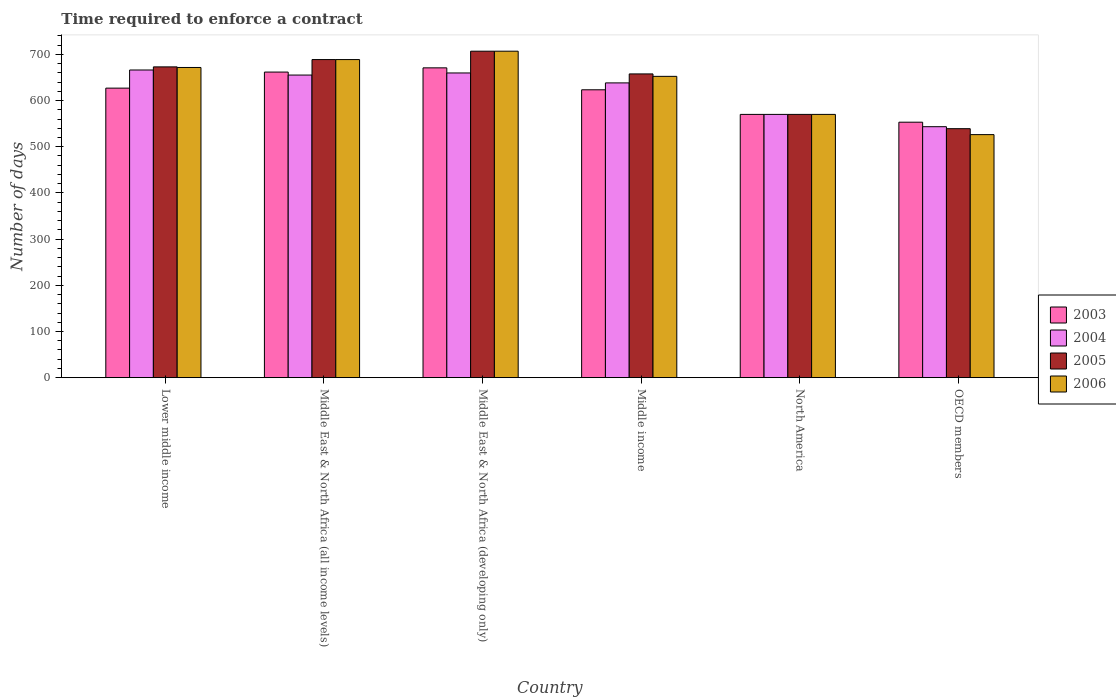How many groups of bars are there?
Provide a succinct answer. 6. Are the number of bars per tick equal to the number of legend labels?
Offer a terse response. Yes. Are the number of bars on each tick of the X-axis equal?
Your answer should be very brief. Yes. How many bars are there on the 2nd tick from the left?
Offer a very short reply. 4. In how many cases, is the number of bars for a given country not equal to the number of legend labels?
Make the answer very short. 0. What is the number of days required to enforce a contract in 2004 in OECD members?
Give a very brief answer. 543.37. Across all countries, what is the maximum number of days required to enforce a contract in 2004?
Keep it short and to the point. 666.15. Across all countries, what is the minimum number of days required to enforce a contract in 2006?
Your answer should be very brief. 526.23. In which country was the number of days required to enforce a contract in 2006 maximum?
Your response must be concise. Middle East & North Africa (developing only). What is the total number of days required to enforce a contract in 2006 in the graph?
Give a very brief answer. 3815.74. What is the difference between the number of days required to enforce a contract in 2004 in Middle East & North Africa (developing only) and that in Middle income?
Provide a short and direct response. 21.52. What is the difference between the number of days required to enforce a contract in 2003 in North America and the number of days required to enforce a contract in 2004 in OECD members?
Your response must be concise. 26.63. What is the average number of days required to enforce a contract in 2004 per country?
Provide a succinct answer. 622.11. What is the difference between the number of days required to enforce a contract of/in 2006 and number of days required to enforce a contract of/in 2004 in North America?
Give a very brief answer. 0. What is the ratio of the number of days required to enforce a contract in 2006 in Middle East & North Africa (all income levels) to that in Middle income?
Give a very brief answer. 1.06. Is the difference between the number of days required to enforce a contract in 2006 in Middle East & North Africa (developing only) and OECD members greater than the difference between the number of days required to enforce a contract in 2004 in Middle East & North Africa (developing only) and OECD members?
Your answer should be very brief. Yes. What is the difference between the highest and the second highest number of days required to enforce a contract in 2006?
Provide a short and direct response. -18.13. What is the difference between the highest and the lowest number of days required to enforce a contract in 2006?
Your answer should be very brief. 180.61. In how many countries, is the number of days required to enforce a contract in 2005 greater than the average number of days required to enforce a contract in 2005 taken over all countries?
Make the answer very short. 4. Is it the case that in every country, the sum of the number of days required to enforce a contract in 2003 and number of days required to enforce a contract in 2004 is greater than the sum of number of days required to enforce a contract in 2005 and number of days required to enforce a contract in 2006?
Keep it short and to the point. No. What does the 3rd bar from the left in Middle income represents?
Ensure brevity in your answer.  2005. Is it the case that in every country, the sum of the number of days required to enforce a contract in 2006 and number of days required to enforce a contract in 2003 is greater than the number of days required to enforce a contract in 2004?
Make the answer very short. Yes. Are all the bars in the graph horizontal?
Ensure brevity in your answer.  No. How many countries are there in the graph?
Offer a very short reply. 6. Are the values on the major ticks of Y-axis written in scientific E-notation?
Keep it short and to the point. No. Does the graph contain grids?
Offer a terse response. No. Where does the legend appear in the graph?
Your answer should be very brief. Center right. How many legend labels are there?
Keep it short and to the point. 4. What is the title of the graph?
Provide a succinct answer. Time required to enforce a contract. Does "1996" appear as one of the legend labels in the graph?
Your response must be concise. No. What is the label or title of the X-axis?
Your response must be concise. Country. What is the label or title of the Y-axis?
Give a very brief answer. Number of days. What is the Number of days in 2003 in Lower middle income?
Provide a short and direct response. 626.86. What is the Number of days in 2004 in Lower middle income?
Ensure brevity in your answer.  666.15. What is the Number of days of 2005 in Lower middle income?
Your answer should be very brief. 672.89. What is the Number of days in 2006 in Lower middle income?
Provide a succinct answer. 671.59. What is the Number of days of 2003 in Middle East & North Africa (all income levels)?
Ensure brevity in your answer.  661.64. What is the Number of days in 2004 in Middle East & North Africa (all income levels)?
Your answer should be very brief. 655.19. What is the Number of days in 2005 in Middle East & North Africa (all income levels)?
Offer a very short reply. 688.71. What is the Number of days in 2006 in Middle East & North Africa (all income levels)?
Keep it short and to the point. 688.71. What is the Number of days of 2003 in Middle East & North Africa (developing only)?
Your response must be concise. 670.78. What is the Number of days in 2004 in Middle East & North Africa (developing only)?
Your response must be concise. 659.73. What is the Number of days of 2005 in Middle East & North Africa (developing only)?
Your response must be concise. 706.83. What is the Number of days of 2006 in Middle East & North Africa (developing only)?
Ensure brevity in your answer.  706.83. What is the Number of days of 2003 in Middle income?
Provide a succinct answer. 623.29. What is the Number of days of 2004 in Middle income?
Offer a very short reply. 638.21. What is the Number of days in 2005 in Middle income?
Offer a terse response. 657.65. What is the Number of days of 2006 in Middle income?
Your response must be concise. 652.38. What is the Number of days of 2003 in North America?
Keep it short and to the point. 570. What is the Number of days of 2004 in North America?
Offer a terse response. 570. What is the Number of days of 2005 in North America?
Your response must be concise. 570. What is the Number of days of 2006 in North America?
Your response must be concise. 570. What is the Number of days of 2003 in OECD members?
Your response must be concise. 553.1. What is the Number of days in 2004 in OECD members?
Give a very brief answer. 543.37. What is the Number of days in 2005 in OECD members?
Keep it short and to the point. 539.07. What is the Number of days of 2006 in OECD members?
Ensure brevity in your answer.  526.23. Across all countries, what is the maximum Number of days in 2003?
Give a very brief answer. 670.78. Across all countries, what is the maximum Number of days in 2004?
Make the answer very short. 666.15. Across all countries, what is the maximum Number of days of 2005?
Provide a short and direct response. 706.83. Across all countries, what is the maximum Number of days in 2006?
Your response must be concise. 706.83. Across all countries, what is the minimum Number of days of 2003?
Provide a short and direct response. 553.1. Across all countries, what is the minimum Number of days of 2004?
Your answer should be very brief. 543.37. Across all countries, what is the minimum Number of days of 2005?
Keep it short and to the point. 539.07. Across all countries, what is the minimum Number of days of 2006?
Your answer should be compact. 526.23. What is the total Number of days of 2003 in the graph?
Your response must be concise. 3705.67. What is the total Number of days in 2004 in the graph?
Keep it short and to the point. 3732.64. What is the total Number of days of 2005 in the graph?
Give a very brief answer. 3835.14. What is the total Number of days of 2006 in the graph?
Provide a short and direct response. 3815.74. What is the difference between the Number of days in 2003 in Lower middle income and that in Middle East & North Africa (all income levels)?
Your response must be concise. -34.79. What is the difference between the Number of days in 2004 in Lower middle income and that in Middle East & North Africa (all income levels)?
Provide a short and direct response. 10.96. What is the difference between the Number of days in 2005 in Lower middle income and that in Middle East & North Africa (all income levels)?
Give a very brief answer. -15.82. What is the difference between the Number of days in 2006 in Lower middle income and that in Middle East & North Africa (all income levels)?
Your response must be concise. -17.11. What is the difference between the Number of days in 2003 in Lower middle income and that in Middle East & North Africa (developing only)?
Ensure brevity in your answer.  -43.92. What is the difference between the Number of days of 2004 in Lower middle income and that in Middle East & North Africa (developing only)?
Your response must be concise. 6.42. What is the difference between the Number of days in 2005 in Lower middle income and that in Middle East & North Africa (developing only)?
Give a very brief answer. -33.95. What is the difference between the Number of days of 2006 in Lower middle income and that in Middle East & North Africa (developing only)?
Provide a short and direct response. -35.24. What is the difference between the Number of days in 2003 in Lower middle income and that in Middle income?
Ensure brevity in your answer.  3.57. What is the difference between the Number of days of 2004 in Lower middle income and that in Middle income?
Make the answer very short. 27.94. What is the difference between the Number of days in 2005 in Lower middle income and that in Middle income?
Provide a short and direct response. 15.24. What is the difference between the Number of days in 2006 in Lower middle income and that in Middle income?
Your response must be concise. 19.21. What is the difference between the Number of days in 2003 in Lower middle income and that in North America?
Your answer should be compact. 56.86. What is the difference between the Number of days in 2004 in Lower middle income and that in North America?
Offer a very short reply. 96.15. What is the difference between the Number of days of 2005 in Lower middle income and that in North America?
Keep it short and to the point. 102.89. What is the difference between the Number of days of 2006 in Lower middle income and that in North America?
Ensure brevity in your answer.  101.59. What is the difference between the Number of days in 2003 in Lower middle income and that in OECD members?
Keep it short and to the point. 73.75. What is the difference between the Number of days of 2004 in Lower middle income and that in OECD members?
Give a very brief answer. 122.78. What is the difference between the Number of days in 2005 in Lower middle income and that in OECD members?
Keep it short and to the point. 133.82. What is the difference between the Number of days in 2006 in Lower middle income and that in OECD members?
Make the answer very short. 145.37. What is the difference between the Number of days of 2003 in Middle East & North Africa (all income levels) and that in Middle East & North Africa (developing only)?
Your answer should be very brief. -9.13. What is the difference between the Number of days in 2004 in Middle East & North Africa (all income levels) and that in Middle East & North Africa (developing only)?
Provide a succinct answer. -4.54. What is the difference between the Number of days of 2005 in Middle East & North Africa (all income levels) and that in Middle East & North Africa (developing only)?
Offer a very short reply. -18.13. What is the difference between the Number of days of 2006 in Middle East & North Africa (all income levels) and that in Middle East & North Africa (developing only)?
Give a very brief answer. -18.13. What is the difference between the Number of days of 2003 in Middle East & North Africa (all income levels) and that in Middle income?
Offer a terse response. 38.36. What is the difference between the Number of days of 2004 in Middle East & North Africa (all income levels) and that in Middle income?
Your answer should be compact. 16.98. What is the difference between the Number of days of 2005 in Middle East & North Africa (all income levels) and that in Middle income?
Your response must be concise. 31.06. What is the difference between the Number of days in 2006 in Middle East & North Africa (all income levels) and that in Middle income?
Your answer should be compact. 36.32. What is the difference between the Number of days in 2003 in Middle East & North Africa (all income levels) and that in North America?
Offer a very short reply. 91.64. What is the difference between the Number of days in 2004 in Middle East & North Africa (all income levels) and that in North America?
Offer a terse response. 85.19. What is the difference between the Number of days of 2005 in Middle East & North Africa (all income levels) and that in North America?
Keep it short and to the point. 118.71. What is the difference between the Number of days in 2006 in Middle East & North Africa (all income levels) and that in North America?
Offer a terse response. 118.71. What is the difference between the Number of days of 2003 in Middle East & North Africa (all income levels) and that in OECD members?
Your response must be concise. 108.54. What is the difference between the Number of days in 2004 in Middle East & North Africa (all income levels) and that in OECD members?
Ensure brevity in your answer.  111.82. What is the difference between the Number of days of 2005 in Middle East & North Africa (all income levels) and that in OECD members?
Your response must be concise. 149.64. What is the difference between the Number of days of 2006 in Middle East & North Africa (all income levels) and that in OECD members?
Keep it short and to the point. 162.48. What is the difference between the Number of days in 2003 in Middle East & North Africa (developing only) and that in Middle income?
Keep it short and to the point. 47.49. What is the difference between the Number of days of 2004 in Middle East & North Africa (developing only) and that in Middle income?
Give a very brief answer. 21.52. What is the difference between the Number of days of 2005 in Middle East & North Africa (developing only) and that in Middle income?
Provide a succinct answer. 49.19. What is the difference between the Number of days of 2006 in Middle East & North Africa (developing only) and that in Middle income?
Your answer should be very brief. 54.45. What is the difference between the Number of days in 2003 in Middle East & North Africa (developing only) and that in North America?
Your answer should be compact. 100.78. What is the difference between the Number of days in 2004 in Middle East & North Africa (developing only) and that in North America?
Offer a very short reply. 89.73. What is the difference between the Number of days in 2005 in Middle East & North Africa (developing only) and that in North America?
Your answer should be very brief. 136.83. What is the difference between the Number of days of 2006 in Middle East & North Africa (developing only) and that in North America?
Provide a succinct answer. 136.83. What is the difference between the Number of days of 2003 in Middle East & North Africa (developing only) and that in OECD members?
Your answer should be compact. 117.67. What is the difference between the Number of days of 2004 in Middle East & North Africa (developing only) and that in OECD members?
Your answer should be very brief. 116.36. What is the difference between the Number of days of 2005 in Middle East & North Africa (developing only) and that in OECD members?
Ensure brevity in your answer.  167.77. What is the difference between the Number of days of 2006 in Middle East & North Africa (developing only) and that in OECD members?
Ensure brevity in your answer.  180.61. What is the difference between the Number of days in 2003 in Middle income and that in North America?
Give a very brief answer. 53.29. What is the difference between the Number of days of 2004 in Middle income and that in North America?
Offer a very short reply. 68.21. What is the difference between the Number of days in 2005 in Middle income and that in North America?
Provide a succinct answer. 87.65. What is the difference between the Number of days of 2006 in Middle income and that in North America?
Provide a succinct answer. 82.38. What is the difference between the Number of days of 2003 in Middle income and that in OECD members?
Provide a succinct answer. 70.18. What is the difference between the Number of days of 2004 in Middle income and that in OECD members?
Make the answer very short. 94.84. What is the difference between the Number of days of 2005 in Middle income and that in OECD members?
Offer a very short reply. 118.58. What is the difference between the Number of days of 2006 in Middle income and that in OECD members?
Your answer should be very brief. 126.16. What is the difference between the Number of days of 2003 in North America and that in OECD members?
Offer a terse response. 16.9. What is the difference between the Number of days in 2004 in North America and that in OECD members?
Offer a very short reply. 26.63. What is the difference between the Number of days in 2005 in North America and that in OECD members?
Provide a succinct answer. 30.93. What is the difference between the Number of days of 2006 in North America and that in OECD members?
Provide a succinct answer. 43.77. What is the difference between the Number of days of 2003 in Lower middle income and the Number of days of 2004 in Middle East & North Africa (all income levels)?
Provide a short and direct response. -28.33. What is the difference between the Number of days of 2003 in Lower middle income and the Number of days of 2005 in Middle East & North Africa (all income levels)?
Keep it short and to the point. -61.85. What is the difference between the Number of days in 2003 in Lower middle income and the Number of days in 2006 in Middle East & North Africa (all income levels)?
Ensure brevity in your answer.  -61.85. What is the difference between the Number of days of 2004 in Lower middle income and the Number of days of 2005 in Middle East & North Africa (all income levels)?
Offer a very short reply. -22.56. What is the difference between the Number of days in 2004 in Lower middle income and the Number of days in 2006 in Middle East & North Africa (all income levels)?
Provide a short and direct response. -22.56. What is the difference between the Number of days in 2005 in Lower middle income and the Number of days in 2006 in Middle East & North Africa (all income levels)?
Your response must be concise. -15.82. What is the difference between the Number of days of 2003 in Lower middle income and the Number of days of 2004 in Middle East & North Africa (developing only)?
Your answer should be very brief. -32.87. What is the difference between the Number of days in 2003 in Lower middle income and the Number of days in 2005 in Middle East & North Africa (developing only)?
Offer a very short reply. -79.98. What is the difference between the Number of days of 2003 in Lower middle income and the Number of days of 2006 in Middle East & North Africa (developing only)?
Provide a short and direct response. -79.98. What is the difference between the Number of days in 2004 in Lower middle income and the Number of days in 2005 in Middle East & North Africa (developing only)?
Keep it short and to the point. -40.68. What is the difference between the Number of days in 2004 in Lower middle income and the Number of days in 2006 in Middle East & North Africa (developing only)?
Keep it short and to the point. -40.68. What is the difference between the Number of days in 2005 in Lower middle income and the Number of days in 2006 in Middle East & North Africa (developing only)?
Keep it short and to the point. -33.95. What is the difference between the Number of days in 2003 in Lower middle income and the Number of days in 2004 in Middle income?
Provide a short and direct response. -11.35. What is the difference between the Number of days of 2003 in Lower middle income and the Number of days of 2005 in Middle income?
Offer a very short reply. -30.79. What is the difference between the Number of days of 2003 in Lower middle income and the Number of days of 2006 in Middle income?
Your response must be concise. -25.52. What is the difference between the Number of days of 2004 in Lower middle income and the Number of days of 2005 in Middle income?
Your response must be concise. 8.5. What is the difference between the Number of days in 2004 in Lower middle income and the Number of days in 2006 in Middle income?
Offer a terse response. 13.77. What is the difference between the Number of days of 2005 in Lower middle income and the Number of days of 2006 in Middle income?
Provide a short and direct response. 20.5. What is the difference between the Number of days of 2003 in Lower middle income and the Number of days of 2004 in North America?
Offer a terse response. 56.86. What is the difference between the Number of days in 2003 in Lower middle income and the Number of days in 2005 in North America?
Your answer should be very brief. 56.86. What is the difference between the Number of days of 2003 in Lower middle income and the Number of days of 2006 in North America?
Your response must be concise. 56.86. What is the difference between the Number of days in 2004 in Lower middle income and the Number of days in 2005 in North America?
Your answer should be very brief. 96.15. What is the difference between the Number of days in 2004 in Lower middle income and the Number of days in 2006 in North America?
Your answer should be very brief. 96.15. What is the difference between the Number of days in 2005 in Lower middle income and the Number of days in 2006 in North America?
Ensure brevity in your answer.  102.89. What is the difference between the Number of days in 2003 in Lower middle income and the Number of days in 2004 in OECD members?
Give a very brief answer. 83.49. What is the difference between the Number of days in 2003 in Lower middle income and the Number of days in 2005 in OECD members?
Offer a terse response. 87.79. What is the difference between the Number of days of 2003 in Lower middle income and the Number of days of 2006 in OECD members?
Your answer should be very brief. 100.63. What is the difference between the Number of days in 2004 in Lower middle income and the Number of days in 2005 in OECD members?
Offer a terse response. 127.08. What is the difference between the Number of days in 2004 in Lower middle income and the Number of days in 2006 in OECD members?
Keep it short and to the point. 139.92. What is the difference between the Number of days of 2005 in Lower middle income and the Number of days of 2006 in OECD members?
Keep it short and to the point. 146.66. What is the difference between the Number of days of 2003 in Middle East & North Africa (all income levels) and the Number of days of 2004 in Middle East & North Africa (developing only)?
Provide a succinct answer. 1.92. What is the difference between the Number of days of 2003 in Middle East & North Africa (all income levels) and the Number of days of 2005 in Middle East & North Africa (developing only)?
Your answer should be very brief. -45.19. What is the difference between the Number of days of 2003 in Middle East & North Africa (all income levels) and the Number of days of 2006 in Middle East & North Africa (developing only)?
Ensure brevity in your answer.  -45.19. What is the difference between the Number of days in 2004 in Middle East & North Africa (all income levels) and the Number of days in 2005 in Middle East & North Africa (developing only)?
Ensure brevity in your answer.  -51.65. What is the difference between the Number of days of 2004 in Middle East & North Africa (all income levels) and the Number of days of 2006 in Middle East & North Africa (developing only)?
Your response must be concise. -51.65. What is the difference between the Number of days of 2005 in Middle East & North Africa (all income levels) and the Number of days of 2006 in Middle East & North Africa (developing only)?
Keep it short and to the point. -18.13. What is the difference between the Number of days in 2003 in Middle East & North Africa (all income levels) and the Number of days in 2004 in Middle income?
Offer a very short reply. 23.44. What is the difference between the Number of days in 2003 in Middle East & North Africa (all income levels) and the Number of days in 2005 in Middle income?
Provide a short and direct response. 4. What is the difference between the Number of days of 2003 in Middle East & North Africa (all income levels) and the Number of days of 2006 in Middle income?
Your response must be concise. 9.26. What is the difference between the Number of days in 2004 in Middle East & North Africa (all income levels) and the Number of days in 2005 in Middle income?
Ensure brevity in your answer.  -2.46. What is the difference between the Number of days of 2004 in Middle East & North Africa (all income levels) and the Number of days of 2006 in Middle income?
Ensure brevity in your answer.  2.81. What is the difference between the Number of days in 2005 in Middle East & North Africa (all income levels) and the Number of days in 2006 in Middle income?
Ensure brevity in your answer.  36.32. What is the difference between the Number of days of 2003 in Middle East & North Africa (all income levels) and the Number of days of 2004 in North America?
Your answer should be compact. 91.64. What is the difference between the Number of days of 2003 in Middle East & North Africa (all income levels) and the Number of days of 2005 in North America?
Your answer should be very brief. 91.64. What is the difference between the Number of days of 2003 in Middle East & North Africa (all income levels) and the Number of days of 2006 in North America?
Keep it short and to the point. 91.64. What is the difference between the Number of days of 2004 in Middle East & North Africa (all income levels) and the Number of days of 2005 in North America?
Make the answer very short. 85.19. What is the difference between the Number of days in 2004 in Middle East & North Africa (all income levels) and the Number of days in 2006 in North America?
Ensure brevity in your answer.  85.19. What is the difference between the Number of days of 2005 in Middle East & North Africa (all income levels) and the Number of days of 2006 in North America?
Ensure brevity in your answer.  118.71. What is the difference between the Number of days of 2003 in Middle East & North Africa (all income levels) and the Number of days of 2004 in OECD members?
Provide a succinct answer. 118.28. What is the difference between the Number of days of 2003 in Middle East & North Africa (all income levels) and the Number of days of 2005 in OECD members?
Provide a short and direct response. 122.58. What is the difference between the Number of days in 2003 in Middle East & North Africa (all income levels) and the Number of days in 2006 in OECD members?
Your response must be concise. 135.42. What is the difference between the Number of days in 2004 in Middle East & North Africa (all income levels) and the Number of days in 2005 in OECD members?
Offer a very short reply. 116.12. What is the difference between the Number of days in 2004 in Middle East & North Africa (all income levels) and the Number of days in 2006 in OECD members?
Give a very brief answer. 128.96. What is the difference between the Number of days in 2005 in Middle East & North Africa (all income levels) and the Number of days in 2006 in OECD members?
Your answer should be compact. 162.48. What is the difference between the Number of days of 2003 in Middle East & North Africa (developing only) and the Number of days of 2004 in Middle income?
Your answer should be very brief. 32.57. What is the difference between the Number of days of 2003 in Middle East & North Africa (developing only) and the Number of days of 2005 in Middle income?
Offer a terse response. 13.13. What is the difference between the Number of days of 2003 in Middle East & North Africa (developing only) and the Number of days of 2006 in Middle income?
Provide a succinct answer. 18.4. What is the difference between the Number of days in 2004 in Middle East & North Africa (developing only) and the Number of days in 2005 in Middle income?
Ensure brevity in your answer.  2.08. What is the difference between the Number of days in 2004 in Middle East & North Africa (developing only) and the Number of days in 2006 in Middle income?
Your response must be concise. 7.35. What is the difference between the Number of days of 2005 in Middle East & North Africa (developing only) and the Number of days of 2006 in Middle income?
Ensure brevity in your answer.  54.45. What is the difference between the Number of days in 2003 in Middle East & North Africa (developing only) and the Number of days in 2004 in North America?
Ensure brevity in your answer.  100.78. What is the difference between the Number of days of 2003 in Middle East & North Africa (developing only) and the Number of days of 2005 in North America?
Offer a terse response. 100.78. What is the difference between the Number of days of 2003 in Middle East & North Africa (developing only) and the Number of days of 2006 in North America?
Your answer should be very brief. 100.78. What is the difference between the Number of days in 2004 in Middle East & North Africa (developing only) and the Number of days in 2005 in North America?
Provide a succinct answer. 89.73. What is the difference between the Number of days of 2004 in Middle East & North Africa (developing only) and the Number of days of 2006 in North America?
Provide a succinct answer. 89.73. What is the difference between the Number of days in 2005 in Middle East & North Africa (developing only) and the Number of days in 2006 in North America?
Your answer should be very brief. 136.83. What is the difference between the Number of days of 2003 in Middle East & North Africa (developing only) and the Number of days of 2004 in OECD members?
Give a very brief answer. 127.41. What is the difference between the Number of days in 2003 in Middle East & North Africa (developing only) and the Number of days in 2005 in OECD members?
Your answer should be compact. 131.71. What is the difference between the Number of days in 2003 in Middle East & North Africa (developing only) and the Number of days in 2006 in OECD members?
Offer a terse response. 144.55. What is the difference between the Number of days of 2004 in Middle East & North Africa (developing only) and the Number of days of 2005 in OECD members?
Ensure brevity in your answer.  120.66. What is the difference between the Number of days of 2004 in Middle East & North Africa (developing only) and the Number of days of 2006 in OECD members?
Give a very brief answer. 133.5. What is the difference between the Number of days of 2005 in Middle East & North Africa (developing only) and the Number of days of 2006 in OECD members?
Your response must be concise. 180.61. What is the difference between the Number of days of 2003 in Middle income and the Number of days of 2004 in North America?
Provide a short and direct response. 53.29. What is the difference between the Number of days in 2003 in Middle income and the Number of days in 2005 in North America?
Provide a succinct answer. 53.29. What is the difference between the Number of days in 2003 in Middle income and the Number of days in 2006 in North America?
Your answer should be compact. 53.29. What is the difference between the Number of days in 2004 in Middle income and the Number of days in 2005 in North America?
Give a very brief answer. 68.21. What is the difference between the Number of days in 2004 in Middle income and the Number of days in 2006 in North America?
Offer a very short reply. 68.21. What is the difference between the Number of days of 2005 in Middle income and the Number of days of 2006 in North America?
Ensure brevity in your answer.  87.65. What is the difference between the Number of days of 2003 in Middle income and the Number of days of 2004 in OECD members?
Keep it short and to the point. 79.92. What is the difference between the Number of days in 2003 in Middle income and the Number of days in 2005 in OECD members?
Make the answer very short. 84.22. What is the difference between the Number of days of 2003 in Middle income and the Number of days of 2006 in OECD members?
Ensure brevity in your answer.  97.06. What is the difference between the Number of days of 2004 in Middle income and the Number of days of 2005 in OECD members?
Your response must be concise. 99.14. What is the difference between the Number of days in 2004 in Middle income and the Number of days in 2006 in OECD members?
Offer a terse response. 111.98. What is the difference between the Number of days in 2005 in Middle income and the Number of days in 2006 in OECD members?
Provide a short and direct response. 131.42. What is the difference between the Number of days of 2003 in North America and the Number of days of 2004 in OECD members?
Offer a terse response. 26.63. What is the difference between the Number of days of 2003 in North America and the Number of days of 2005 in OECD members?
Offer a terse response. 30.93. What is the difference between the Number of days of 2003 in North America and the Number of days of 2006 in OECD members?
Keep it short and to the point. 43.77. What is the difference between the Number of days of 2004 in North America and the Number of days of 2005 in OECD members?
Your response must be concise. 30.93. What is the difference between the Number of days of 2004 in North America and the Number of days of 2006 in OECD members?
Your response must be concise. 43.77. What is the difference between the Number of days of 2005 in North America and the Number of days of 2006 in OECD members?
Ensure brevity in your answer.  43.77. What is the average Number of days of 2003 per country?
Give a very brief answer. 617.61. What is the average Number of days in 2004 per country?
Provide a short and direct response. 622.11. What is the average Number of days in 2005 per country?
Your answer should be compact. 639.19. What is the average Number of days of 2006 per country?
Provide a short and direct response. 635.96. What is the difference between the Number of days in 2003 and Number of days in 2004 in Lower middle income?
Offer a terse response. -39.29. What is the difference between the Number of days in 2003 and Number of days in 2005 in Lower middle income?
Keep it short and to the point. -46.03. What is the difference between the Number of days in 2003 and Number of days in 2006 in Lower middle income?
Offer a very short reply. -44.73. What is the difference between the Number of days of 2004 and Number of days of 2005 in Lower middle income?
Provide a succinct answer. -6.74. What is the difference between the Number of days in 2004 and Number of days in 2006 in Lower middle income?
Your answer should be compact. -5.44. What is the difference between the Number of days of 2005 and Number of days of 2006 in Lower middle income?
Keep it short and to the point. 1.3. What is the difference between the Number of days of 2003 and Number of days of 2004 in Middle East & North Africa (all income levels)?
Offer a terse response. 6.46. What is the difference between the Number of days of 2003 and Number of days of 2005 in Middle East & North Africa (all income levels)?
Keep it short and to the point. -27.06. What is the difference between the Number of days of 2003 and Number of days of 2006 in Middle East & North Africa (all income levels)?
Provide a succinct answer. -27.06. What is the difference between the Number of days of 2004 and Number of days of 2005 in Middle East & North Africa (all income levels)?
Ensure brevity in your answer.  -33.52. What is the difference between the Number of days of 2004 and Number of days of 2006 in Middle East & North Africa (all income levels)?
Give a very brief answer. -33.52. What is the difference between the Number of days in 2005 and Number of days in 2006 in Middle East & North Africa (all income levels)?
Your answer should be compact. 0. What is the difference between the Number of days in 2003 and Number of days in 2004 in Middle East & North Africa (developing only)?
Your response must be concise. 11.05. What is the difference between the Number of days in 2003 and Number of days in 2005 in Middle East & North Africa (developing only)?
Provide a short and direct response. -36.06. What is the difference between the Number of days in 2003 and Number of days in 2006 in Middle East & North Africa (developing only)?
Offer a terse response. -36.06. What is the difference between the Number of days in 2004 and Number of days in 2005 in Middle East & North Africa (developing only)?
Provide a succinct answer. -47.11. What is the difference between the Number of days of 2004 and Number of days of 2006 in Middle East & North Africa (developing only)?
Give a very brief answer. -47.11. What is the difference between the Number of days in 2003 and Number of days in 2004 in Middle income?
Your answer should be compact. -14.92. What is the difference between the Number of days of 2003 and Number of days of 2005 in Middle income?
Make the answer very short. -34.36. What is the difference between the Number of days in 2003 and Number of days in 2006 in Middle income?
Offer a very short reply. -29.1. What is the difference between the Number of days in 2004 and Number of days in 2005 in Middle income?
Ensure brevity in your answer.  -19.44. What is the difference between the Number of days of 2004 and Number of days of 2006 in Middle income?
Keep it short and to the point. -14.17. What is the difference between the Number of days in 2005 and Number of days in 2006 in Middle income?
Ensure brevity in your answer.  5.27. What is the difference between the Number of days in 2003 and Number of days in 2005 in North America?
Offer a terse response. 0. What is the difference between the Number of days of 2003 and Number of days of 2006 in North America?
Your answer should be very brief. 0. What is the difference between the Number of days of 2004 and Number of days of 2006 in North America?
Your answer should be very brief. 0. What is the difference between the Number of days in 2003 and Number of days in 2004 in OECD members?
Your answer should be compact. 9.74. What is the difference between the Number of days of 2003 and Number of days of 2005 in OECD members?
Provide a succinct answer. 14.04. What is the difference between the Number of days in 2003 and Number of days in 2006 in OECD members?
Offer a terse response. 26.88. What is the difference between the Number of days in 2004 and Number of days in 2005 in OECD members?
Your answer should be compact. 4.3. What is the difference between the Number of days in 2004 and Number of days in 2006 in OECD members?
Provide a short and direct response. 17.14. What is the difference between the Number of days in 2005 and Number of days in 2006 in OECD members?
Give a very brief answer. 12.84. What is the ratio of the Number of days of 2004 in Lower middle income to that in Middle East & North Africa (all income levels)?
Your answer should be very brief. 1.02. What is the ratio of the Number of days in 2006 in Lower middle income to that in Middle East & North Africa (all income levels)?
Your answer should be compact. 0.98. What is the ratio of the Number of days of 2003 in Lower middle income to that in Middle East & North Africa (developing only)?
Make the answer very short. 0.93. What is the ratio of the Number of days in 2004 in Lower middle income to that in Middle East & North Africa (developing only)?
Provide a short and direct response. 1.01. What is the ratio of the Number of days in 2005 in Lower middle income to that in Middle East & North Africa (developing only)?
Provide a succinct answer. 0.95. What is the ratio of the Number of days of 2006 in Lower middle income to that in Middle East & North Africa (developing only)?
Your response must be concise. 0.95. What is the ratio of the Number of days in 2003 in Lower middle income to that in Middle income?
Your answer should be very brief. 1.01. What is the ratio of the Number of days in 2004 in Lower middle income to that in Middle income?
Offer a terse response. 1.04. What is the ratio of the Number of days in 2005 in Lower middle income to that in Middle income?
Provide a short and direct response. 1.02. What is the ratio of the Number of days in 2006 in Lower middle income to that in Middle income?
Your response must be concise. 1.03. What is the ratio of the Number of days in 2003 in Lower middle income to that in North America?
Your answer should be compact. 1.1. What is the ratio of the Number of days in 2004 in Lower middle income to that in North America?
Offer a very short reply. 1.17. What is the ratio of the Number of days of 2005 in Lower middle income to that in North America?
Ensure brevity in your answer.  1.18. What is the ratio of the Number of days of 2006 in Lower middle income to that in North America?
Your response must be concise. 1.18. What is the ratio of the Number of days in 2003 in Lower middle income to that in OECD members?
Offer a terse response. 1.13. What is the ratio of the Number of days of 2004 in Lower middle income to that in OECD members?
Make the answer very short. 1.23. What is the ratio of the Number of days of 2005 in Lower middle income to that in OECD members?
Ensure brevity in your answer.  1.25. What is the ratio of the Number of days in 2006 in Lower middle income to that in OECD members?
Your answer should be very brief. 1.28. What is the ratio of the Number of days in 2003 in Middle East & North Africa (all income levels) to that in Middle East & North Africa (developing only)?
Your answer should be compact. 0.99. What is the ratio of the Number of days in 2005 in Middle East & North Africa (all income levels) to that in Middle East & North Africa (developing only)?
Provide a succinct answer. 0.97. What is the ratio of the Number of days of 2006 in Middle East & North Africa (all income levels) to that in Middle East & North Africa (developing only)?
Your response must be concise. 0.97. What is the ratio of the Number of days in 2003 in Middle East & North Africa (all income levels) to that in Middle income?
Ensure brevity in your answer.  1.06. What is the ratio of the Number of days of 2004 in Middle East & North Africa (all income levels) to that in Middle income?
Keep it short and to the point. 1.03. What is the ratio of the Number of days of 2005 in Middle East & North Africa (all income levels) to that in Middle income?
Your answer should be very brief. 1.05. What is the ratio of the Number of days in 2006 in Middle East & North Africa (all income levels) to that in Middle income?
Give a very brief answer. 1.06. What is the ratio of the Number of days in 2003 in Middle East & North Africa (all income levels) to that in North America?
Your response must be concise. 1.16. What is the ratio of the Number of days in 2004 in Middle East & North Africa (all income levels) to that in North America?
Your answer should be compact. 1.15. What is the ratio of the Number of days in 2005 in Middle East & North Africa (all income levels) to that in North America?
Offer a very short reply. 1.21. What is the ratio of the Number of days of 2006 in Middle East & North Africa (all income levels) to that in North America?
Ensure brevity in your answer.  1.21. What is the ratio of the Number of days in 2003 in Middle East & North Africa (all income levels) to that in OECD members?
Offer a terse response. 1.2. What is the ratio of the Number of days of 2004 in Middle East & North Africa (all income levels) to that in OECD members?
Your response must be concise. 1.21. What is the ratio of the Number of days of 2005 in Middle East & North Africa (all income levels) to that in OECD members?
Your answer should be compact. 1.28. What is the ratio of the Number of days of 2006 in Middle East & North Africa (all income levels) to that in OECD members?
Provide a short and direct response. 1.31. What is the ratio of the Number of days in 2003 in Middle East & North Africa (developing only) to that in Middle income?
Make the answer very short. 1.08. What is the ratio of the Number of days of 2004 in Middle East & North Africa (developing only) to that in Middle income?
Your answer should be compact. 1.03. What is the ratio of the Number of days in 2005 in Middle East & North Africa (developing only) to that in Middle income?
Your answer should be very brief. 1.07. What is the ratio of the Number of days of 2006 in Middle East & North Africa (developing only) to that in Middle income?
Your response must be concise. 1.08. What is the ratio of the Number of days of 2003 in Middle East & North Africa (developing only) to that in North America?
Your answer should be very brief. 1.18. What is the ratio of the Number of days of 2004 in Middle East & North Africa (developing only) to that in North America?
Make the answer very short. 1.16. What is the ratio of the Number of days in 2005 in Middle East & North Africa (developing only) to that in North America?
Make the answer very short. 1.24. What is the ratio of the Number of days in 2006 in Middle East & North Africa (developing only) to that in North America?
Your answer should be compact. 1.24. What is the ratio of the Number of days in 2003 in Middle East & North Africa (developing only) to that in OECD members?
Ensure brevity in your answer.  1.21. What is the ratio of the Number of days of 2004 in Middle East & North Africa (developing only) to that in OECD members?
Keep it short and to the point. 1.21. What is the ratio of the Number of days in 2005 in Middle East & North Africa (developing only) to that in OECD members?
Offer a very short reply. 1.31. What is the ratio of the Number of days of 2006 in Middle East & North Africa (developing only) to that in OECD members?
Provide a short and direct response. 1.34. What is the ratio of the Number of days in 2003 in Middle income to that in North America?
Make the answer very short. 1.09. What is the ratio of the Number of days in 2004 in Middle income to that in North America?
Make the answer very short. 1.12. What is the ratio of the Number of days of 2005 in Middle income to that in North America?
Make the answer very short. 1.15. What is the ratio of the Number of days of 2006 in Middle income to that in North America?
Offer a very short reply. 1.14. What is the ratio of the Number of days in 2003 in Middle income to that in OECD members?
Give a very brief answer. 1.13. What is the ratio of the Number of days of 2004 in Middle income to that in OECD members?
Your answer should be very brief. 1.17. What is the ratio of the Number of days of 2005 in Middle income to that in OECD members?
Your answer should be compact. 1.22. What is the ratio of the Number of days in 2006 in Middle income to that in OECD members?
Your answer should be compact. 1.24. What is the ratio of the Number of days in 2003 in North America to that in OECD members?
Offer a terse response. 1.03. What is the ratio of the Number of days in 2004 in North America to that in OECD members?
Provide a short and direct response. 1.05. What is the ratio of the Number of days of 2005 in North America to that in OECD members?
Give a very brief answer. 1.06. What is the ratio of the Number of days in 2006 in North America to that in OECD members?
Offer a very short reply. 1.08. What is the difference between the highest and the second highest Number of days of 2003?
Your answer should be very brief. 9.13. What is the difference between the highest and the second highest Number of days of 2004?
Your response must be concise. 6.42. What is the difference between the highest and the second highest Number of days in 2005?
Ensure brevity in your answer.  18.13. What is the difference between the highest and the second highest Number of days of 2006?
Your answer should be compact. 18.13. What is the difference between the highest and the lowest Number of days in 2003?
Your answer should be compact. 117.67. What is the difference between the highest and the lowest Number of days of 2004?
Offer a very short reply. 122.78. What is the difference between the highest and the lowest Number of days of 2005?
Your response must be concise. 167.77. What is the difference between the highest and the lowest Number of days of 2006?
Your response must be concise. 180.61. 